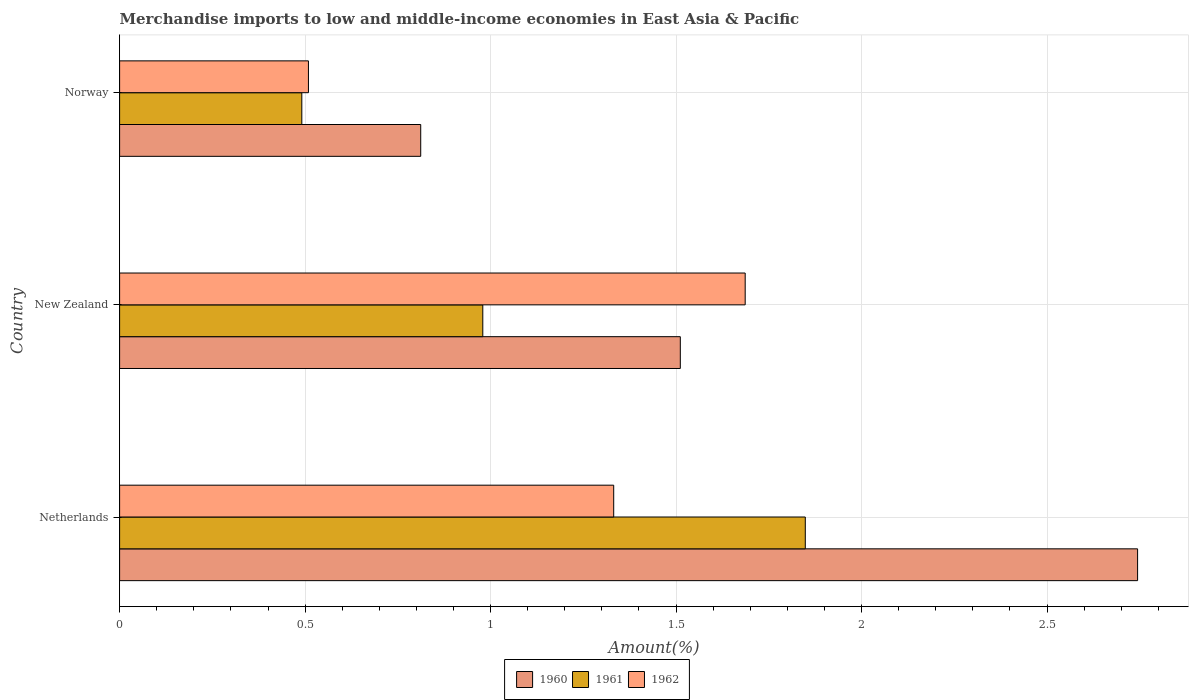How many groups of bars are there?
Your answer should be compact. 3. Are the number of bars per tick equal to the number of legend labels?
Provide a short and direct response. Yes. How many bars are there on the 2nd tick from the top?
Provide a short and direct response. 3. How many bars are there on the 3rd tick from the bottom?
Keep it short and to the point. 3. What is the percentage of amount earned from merchandise imports in 1961 in Netherlands?
Keep it short and to the point. 1.85. Across all countries, what is the maximum percentage of amount earned from merchandise imports in 1960?
Make the answer very short. 2.74. Across all countries, what is the minimum percentage of amount earned from merchandise imports in 1960?
Offer a very short reply. 0.81. In which country was the percentage of amount earned from merchandise imports in 1960 minimum?
Provide a succinct answer. Norway. What is the total percentage of amount earned from merchandise imports in 1960 in the graph?
Offer a very short reply. 5.07. What is the difference between the percentage of amount earned from merchandise imports in 1962 in Netherlands and that in New Zealand?
Offer a very short reply. -0.35. What is the difference between the percentage of amount earned from merchandise imports in 1961 in New Zealand and the percentage of amount earned from merchandise imports in 1960 in Norway?
Offer a terse response. 0.17. What is the average percentage of amount earned from merchandise imports in 1961 per country?
Provide a short and direct response. 1.11. What is the difference between the percentage of amount earned from merchandise imports in 1961 and percentage of amount earned from merchandise imports in 1960 in Netherlands?
Offer a terse response. -0.9. In how many countries, is the percentage of amount earned from merchandise imports in 1962 greater than 2.2 %?
Your answer should be very brief. 0. What is the ratio of the percentage of amount earned from merchandise imports in 1960 in New Zealand to that in Norway?
Your response must be concise. 1.86. What is the difference between the highest and the second highest percentage of amount earned from merchandise imports in 1961?
Make the answer very short. 0.87. What is the difference between the highest and the lowest percentage of amount earned from merchandise imports in 1961?
Ensure brevity in your answer.  1.36. What does the 2nd bar from the top in Netherlands represents?
Ensure brevity in your answer.  1961. Are all the bars in the graph horizontal?
Your response must be concise. Yes. How many countries are there in the graph?
Offer a terse response. 3. Does the graph contain any zero values?
Make the answer very short. No. Where does the legend appear in the graph?
Provide a short and direct response. Bottom center. How are the legend labels stacked?
Provide a succinct answer. Horizontal. What is the title of the graph?
Offer a terse response. Merchandise imports to low and middle-income economies in East Asia & Pacific. Does "1991" appear as one of the legend labels in the graph?
Your response must be concise. No. What is the label or title of the X-axis?
Provide a succinct answer. Amount(%). What is the Amount(%) of 1960 in Netherlands?
Offer a very short reply. 2.74. What is the Amount(%) of 1961 in Netherlands?
Your answer should be compact. 1.85. What is the Amount(%) in 1962 in Netherlands?
Offer a terse response. 1.33. What is the Amount(%) in 1960 in New Zealand?
Give a very brief answer. 1.51. What is the Amount(%) of 1961 in New Zealand?
Your answer should be compact. 0.98. What is the Amount(%) in 1962 in New Zealand?
Your response must be concise. 1.69. What is the Amount(%) of 1960 in Norway?
Provide a succinct answer. 0.81. What is the Amount(%) of 1961 in Norway?
Make the answer very short. 0.49. What is the Amount(%) in 1962 in Norway?
Provide a succinct answer. 0.51. Across all countries, what is the maximum Amount(%) of 1960?
Ensure brevity in your answer.  2.74. Across all countries, what is the maximum Amount(%) in 1961?
Offer a terse response. 1.85. Across all countries, what is the maximum Amount(%) in 1962?
Your response must be concise. 1.69. Across all countries, what is the minimum Amount(%) of 1960?
Offer a very short reply. 0.81. Across all countries, what is the minimum Amount(%) in 1961?
Make the answer very short. 0.49. Across all countries, what is the minimum Amount(%) of 1962?
Provide a short and direct response. 0.51. What is the total Amount(%) of 1960 in the graph?
Provide a succinct answer. 5.07. What is the total Amount(%) in 1961 in the graph?
Provide a succinct answer. 3.32. What is the total Amount(%) in 1962 in the graph?
Give a very brief answer. 3.53. What is the difference between the Amount(%) in 1960 in Netherlands and that in New Zealand?
Your answer should be very brief. 1.23. What is the difference between the Amount(%) of 1961 in Netherlands and that in New Zealand?
Give a very brief answer. 0.87. What is the difference between the Amount(%) in 1962 in Netherlands and that in New Zealand?
Provide a short and direct response. -0.35. What is the difference between the Amount(%) of 1960 in Netherlands and that in Norway?
Make the answer very short. 1.93. What is the difference between the Amount(%) in 1961 in Netherlands and that in Norway?
Ensure brevity in your answer.  1.36. What is the difference between the Amount(%) in 1962 in Netherlands and that in Norway?
Your answer should be compact. 0.82. What is the difference between the Amount(%) of 1960 in New Zealand and that in Norway?
Offer a terse response. 0.7. What is the difference between the Amount(%) of 1961 in New Zealand and that in Norway?
Your response must be concise. 0.49. What is the difference between the Amount(%) of 1962 in New Zealand and that in Norway?
Provide a short and direct response. 1.18. What is the difference between the Amount(%) in 1960 in Netherlands and the Amount(%) in 1961 in New Zealand?
Offer a terse response. 1.76. What is the difference between the Amount(%) in 1960 in Netherlands and the Amount(%) in 1962 in New Zealand?
Your answer should be very brief. 1.06. What is the difference between the Amount(%) in 1961 in Netherlands and the Amount(%) in 1962 in New Zealand?
Provide a short and direct response. 0.16. What is the difference between the Amount(%) in 1960 in Netherlands and the Amount(%) in 1961 in Norway?
Your answer should be compact. 2.25. What is the difference between the Amount(%) in 1960 in Netherlands and the Amount(%) in 1962 in Norway?
Offer a terse response. 2.23. What is the difference between the Amount(%) in 1961 in Netherlands and the Amount(%) in 1962 in Norway?
Make the answer very short. 1.34. What is the difference between the Amount(%) in 1960 in New Zealand and the Amount(%) in 1961 in Norway?
Your response must be concise. 1.02. What is the difference between the Amount(%) of 1960 in New Zealand and the Amount(%) of 1962 in Norway?
Provide a short and direct response. 1. What is the difference between the Amount(%) of 1961 in New Zealand and the Amount(%) of 1962 in Norway?
Offer a very short reply. 0.47. What is the average Amount(%) in 1960 per country?
Ensure brevity in your answer.  1.69. What is the average Amount(%) of 1961 per country?
Offer a very short reply. 1.11. What is the average Amount(%) of 1962 per country?
Make the answer very short. 1.18. What is the difference between the Amount(%) in 1960 and Amount(%) in 1961 in Netherlands?
Give a very brief answer. 0.9. What is the difference between the Amount(%) in 1960 and Amount(%) in 1962 in Netherlands?
Your response must be concise. 1.41. What is the difference between the Amount(%) of 1961 and Amount(%) of 1962 in Netherlands?
Make the answer very short. 0.52. What is the difference between the Amount(%) of 1960 and Amount(%) of 1961 in New Zealand?
Make the answer very short. 0.53. What is the difference between the Amount(%) of 1960 and Amount(%) of 1962 in New Zealand?
Your answer should be compact. -0.17. What is the difference between the Amount(%) of 1961 and Amount(%) of 1962 in New Zealand?
Keep it short and to the point. -0.71. What is the difference between the Amount(%) in 1960 and Amount(%) in 1961 in Norway?
Offer a terse response. 0.32. What is the difference between the Amount(%) of 1960 and Amount(%) of 1962 in Norway?
Your answer should be very brief. 0.3. What is the difference between the Amount(%) in 1961 and Amount(%) in 1962 in Norway?
Provide a succinct answer. -0.02. What is the ratio of the Amount(%) of 1960 in Netherlands to that in New Zealand?
Offer a very short reply. 1.82. What is the ratio of the Amount(%) in 1961 in Netherlands to that in New Zealand?
Offer a terse response. 1.89. What is the ratio of the Amount(%) in 1962 in Netherlands to that in New Zealand?
Provide a succinct answer. 0.79. What is the ratio of the Amount(%) in 1960 in Netherlands to that in Norway?
Your response must be concise. 3.38. What is the ratio of the Amount(%) in 1961 in Netherlands to that in Norway?
Provide a short and direct response. 3.76. What is the ratio of the Amount(%) in 1962 in Netherlands to that in Norway?
Your answer should be compact. 2.62. What is the ratio of the Amount(%) of 1960 in New Zealand to that in Norway?
Make the answer very short. 1.86. What is the ratio of the Amount(%) of 1961 in New Zealand to that in Norway?
Ensure brevity in your answer.  1.99. What is the ratio of the Amount(%) of 1962 in New Zealand to that in Norway?
Your answer should be very brief. 3.31. What is the difference between the highest and the second highest Amount(%) in 1960?
Ensure brevity in your answer.  1.23. What is the difference between the highest and the second highest Amount(%) of 1961?
Offer a very short reply. 0.87. What is the difference between the highest and the second highest Amount(%) of 1962?
Your answer should be compact. 0.35. What is the difference between the highest and the lowest Amount(%) in 1960?
Give a very brief answer. 1.93. What is the difference between the highest and the lowest Amount(%) in 1961?
Provide a succinct answer. 1.36. What is the difference between the highest and the lowest Amount(%) of 1962?
Keep it short and to the point. 1.18. 